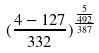<formula> <loc_0><loc_0><loc_500><loc_500>( \frac { 4 - 1 2 7 } { 3 3 2 } ) ^ { \frac { \frac { 5 } { 4 9 2 } } { 3 8 7 } }</formula> 